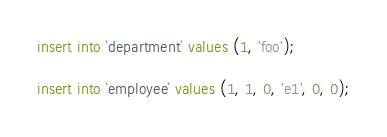<code> <loc_0><loc_0><loc_500><loc_500><_SQL_>insert into `department` values (1, 'foo');

insert into `employee` values (1, 1, 0, 'e1', 0, 0);
</code> 